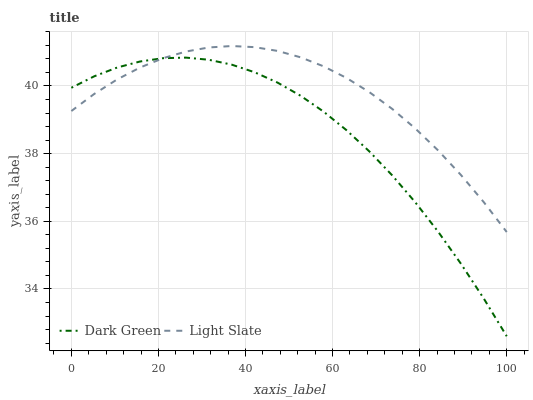Does Dark Green have the minimum area under the curve?
Answer yes or no. Yes. Does Light Slate have the maximum area under the curve?
Answer yes or no. Yes. Does Dark Green have the maximum area under the curve?
Answer yes or no. No. Is Light Slate the smoothest?
Answer yes or no. Yes. Is Dark Green the roughest?
Answer yes or no. Yes. Is Dark Green the smoothest?
Answer yes or no. No. Does Dark Green have the lowest value?
Answer yes or no. Yes. Does Light Slate have the highest value?
Answer yes or no. Yes. Does Dark Green have the highest value?
Answer yes or no. No. Does Light Slate intersect Dark Green?
Answer yes or no. Yes. Is Light Slate less than Dark Green?
Answer yes or no. No. Is Light Slate greater than Dark Green?
Answer yes or no. No. 